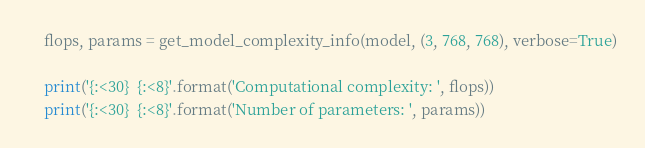<code> <loc_0><loc_0><loc_500><loc_500><_Python_>    flops, params = get_model_complexity_info(model, (3, 768, 768), verbose=True)

    print('{:<30}  {:<8}'.format('Computational complexity: ', flops))
    print('{:<30}  {:<8}'.format('Number of parameters: ', params))
</code> 